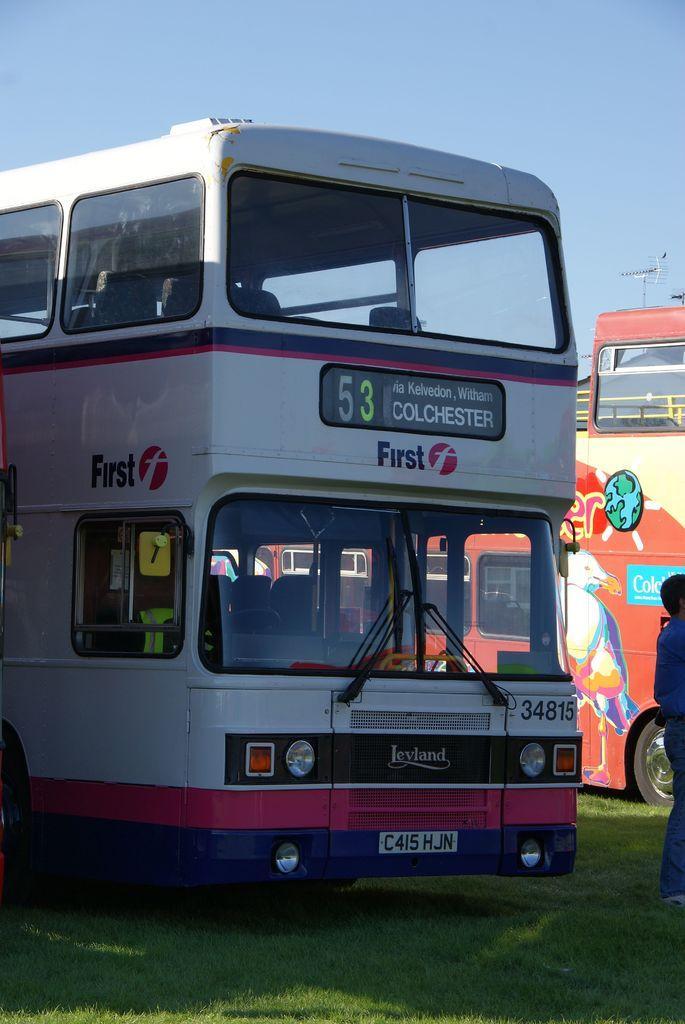How would you summarize this image in a sentence or two? In this picture there are buses on the grass and there is a text on the grass. On the right side of the image there is a person standing. At the top there is sky. At the bottom there is grass. 